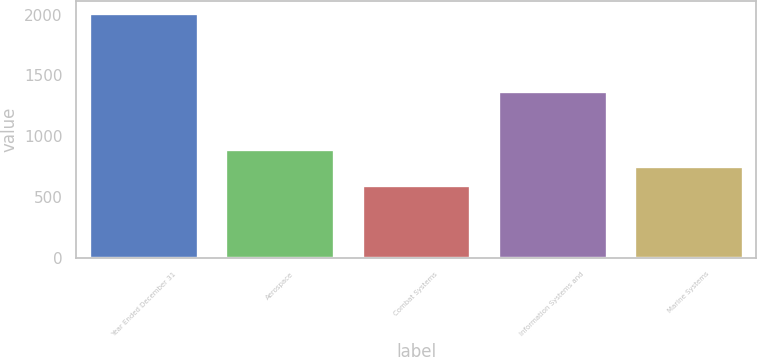<chart> <loc_0><loc_0><loc_500><loc_500><bar_chart><fcel>Year Ended December 31<fcel>Aerospace<fcel>Combat Systems<fcel>Information Systems and<fcel>Marine Systems<nl><fcel>2012<fcel>891.7<fcel>595<fcel>1369<fcel>750<nl></chart> 